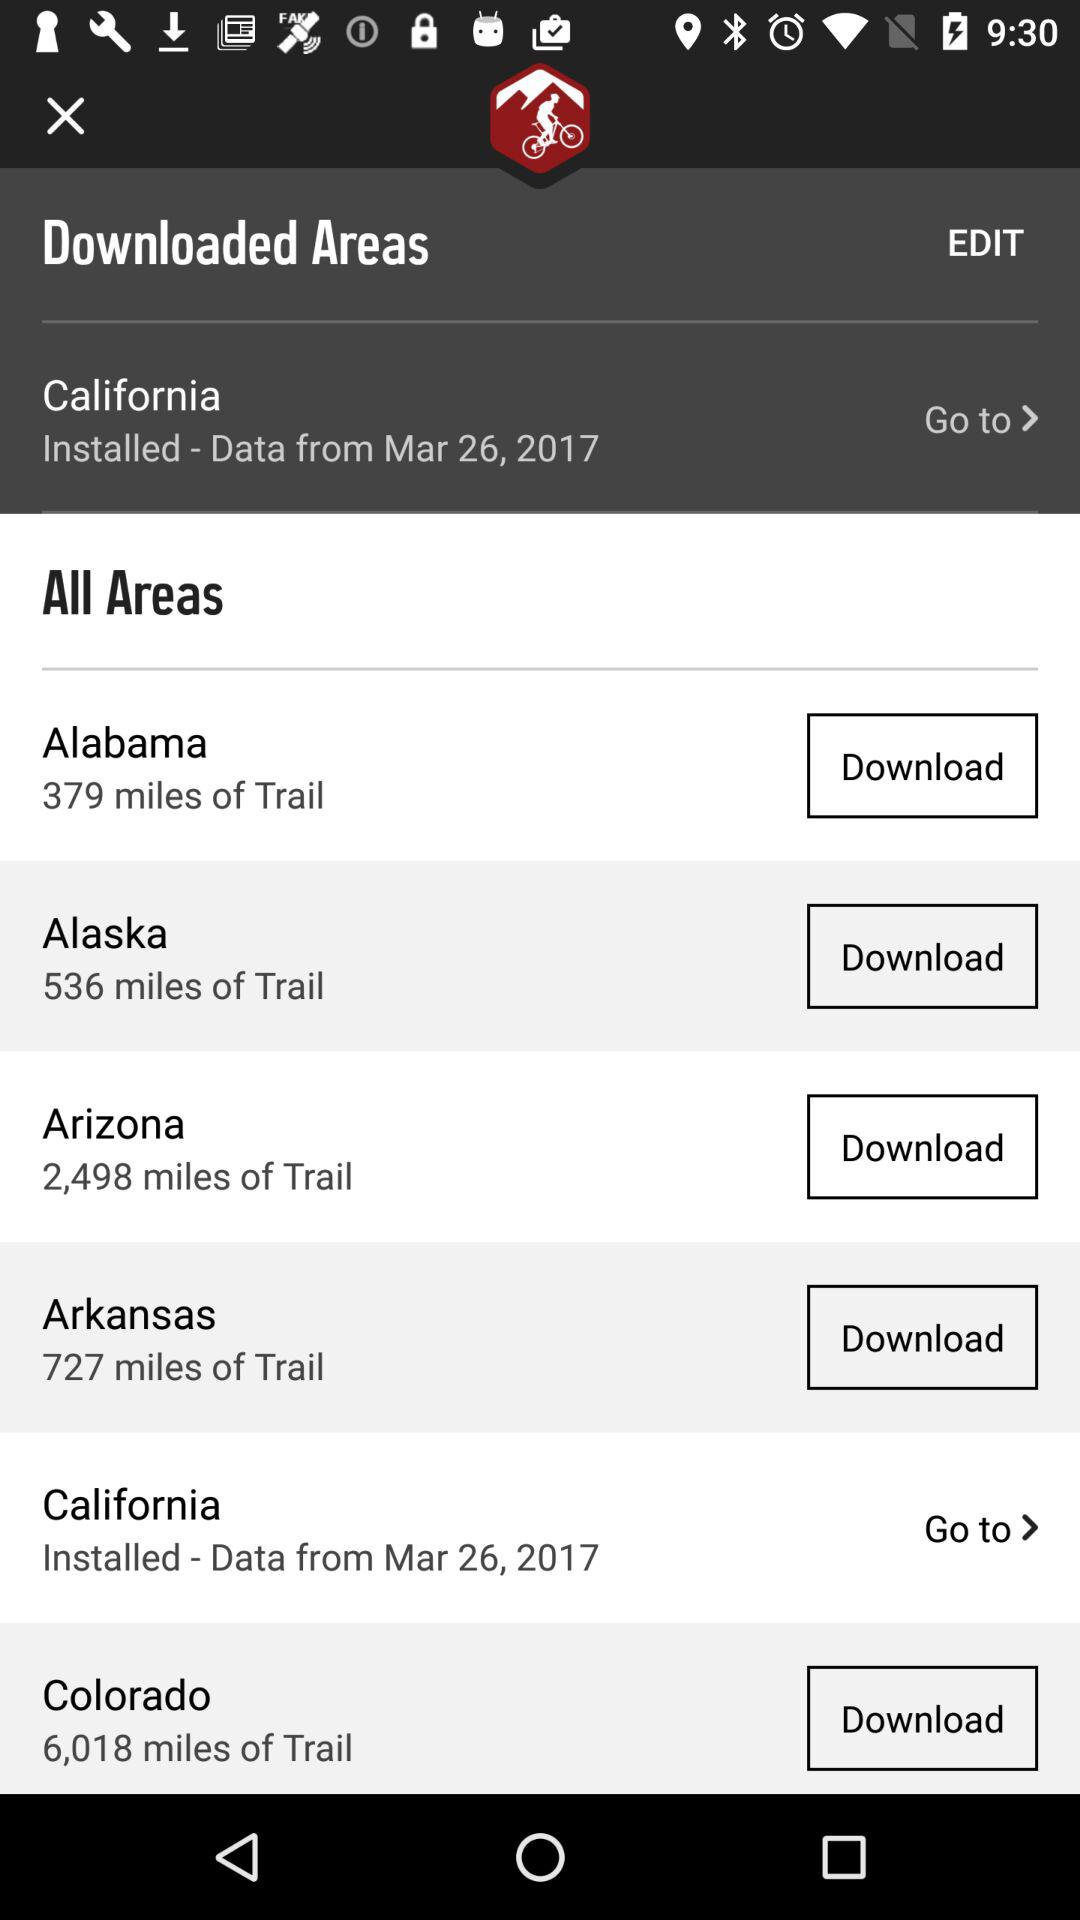What area does the 536 miles of trail belong to? 536 miles of trail belong to Alaska. 